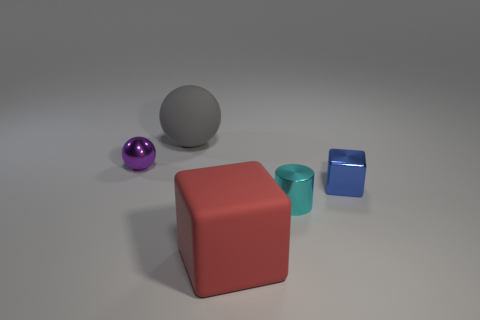There is a thing that is in front of the cyan metallic cylinder; is its color the same as the matte sphere?
Your answer should be very brief. No. There is another metallic thing that is the same shape as the big red object; what is its size?
Your answer should be compact. Small. What number of things are the same material as the cyan cylinder?
Keep it short and to the point. 2. Is there a metallic object right of the large rubber object in front of the big object that is behind the cyan cylinder?
Ensure brevity in your answer.  Yes. What is the shape of the blue shiny thing?
Offer a very short reply. Cube. Are the object that is left of the gray object and the block behind the big block made of the same material?
Provide a short and direct response. Yes. What number of small metallic cubes are the same color as the rubber block?
Your answer should be very brief. 0. The small metal object that is to the left of the blue metallic object and to the right of the purple ball has what shape?
Provide a succinct answer. Cylinder. What is the color of the small object that is behind the metal cylinder and to the right of the purple ball?
Keep it short and to the point. Blue. Is the number of tiny metal spheres that are behind the gray thing greater than the number of big gray objects on the right side of the cylinder?
Your answer should be very brief. No. 